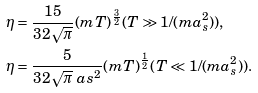<formula> <loc_0><loc_0><loc_500><loc_500>& \eta = \frac { 1 5 } { 3 2 \sqrt { \pi } } ( m T ) ^ { \frac { 3 } { 2 } } ( T \gg 1 / ( m a _ { s } ^ { 2 } ) ) , \\ & \eta = \frac { 5 } { 3 2 \sqrt { \pi } \ a s ^ { 2 } } ( m T ) ^ { \frac { 1 } { 2 } } ( T \ll 1 / ( m a _ { s } ^ { 2 } ) ) .</formula> 